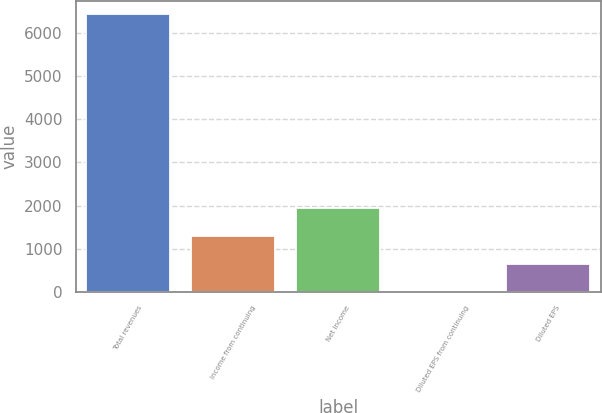Convert chart to OTSL. <chart><loc_0><loc_0><loc_500><loc_500><bar_chart><fcel>Total revenues<fcel>Income from continuing<fcel>Net Income<fcel>Diluted EPS from continuing<fcel>Diluted EPS<nl><fcel>6440<fcel>1289.69<fcel>1933.48<fcel>2.11<fcel>645.9<nl></chart> 